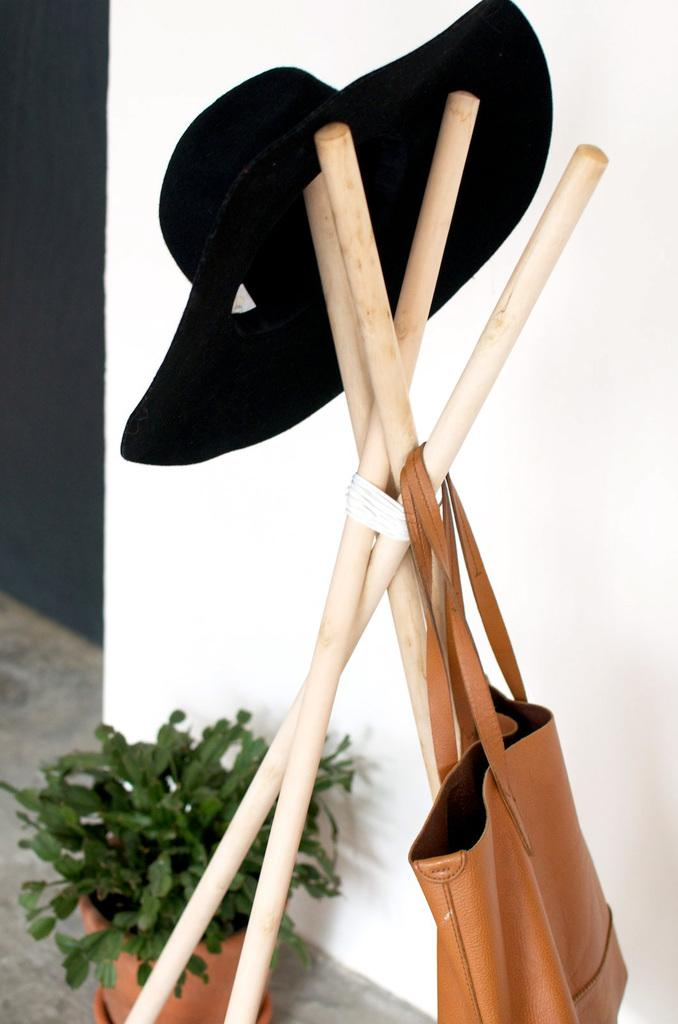What type of headwear is visible in the image? There is a hat in the image. What objects are present that can be used for support or construction? There are sticks in the image. What type of bag can be seen in the image? There is a leather bag in the image. What type of plant is visible in the image? There is a plant in the image. What type of container is present in the image? There is a pot in the image. What type of dishware is visible in the image? There is a plate in the image. What color is the wall in the image? The wall in the image is white. What part of the room can be seen in the image? The floor is visible in the image. What color is the ash-colored element in the image? There is an ash color element in the image, but the specific color is not mentioned in the facts. Can you tell me how many rings are on the plant in the image? There is no mention of rings in the image, as it features a plant in a pot and other objects like a hat, sticks, and a leather bag. Is there a fireman present in the image? There is no mention of a fireman in the image, as it features various objects and a plant in a pot. 